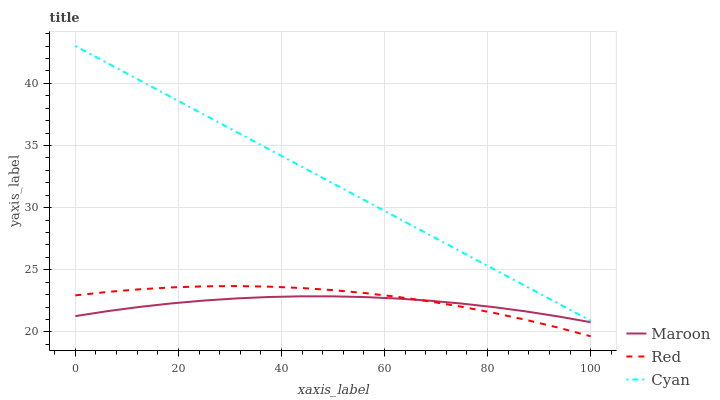Does Maroon have the minimum area under the curve?
Answer yes or no. Yes. Does Cyan have the maximum area under the curve?
Answer yes or no. Yes. Does Red have the minimum area under the curve?
Answer yes or no. No. Does Red have the maximum area under the curve?
Answer yes or no. No. Is Cyan the smoothest?
Answer yes or no. Yes. Is Red the roughest?
Answer yes or no. Yes. Is Maroon the smoothest?
Answer yes or no. No. Is Maroon the roughest?
Answer yes or no. No. Does Red have the lowest value?
Answer yes or no. Yes. Does Maroon have the lowest value?
Answer yes or no. No. Does Cyan have the highest value?
Answer yes or no. Yes. Does Red have the highest value?
Answer yes or no. No. Is Red less than Cyan?
Answer yes or no. Yes. Is Cyan greater than Red?
Answer yes or no. Yes. Does Red intersect Maroon?
Answer yes or no. Yes. Is Red less than Maroon?
Answer yes or no. No. Is Red greater than Maroon?
Answer yes or no. No. Does Red intersect Cyan?
Answer yes or no. No. 